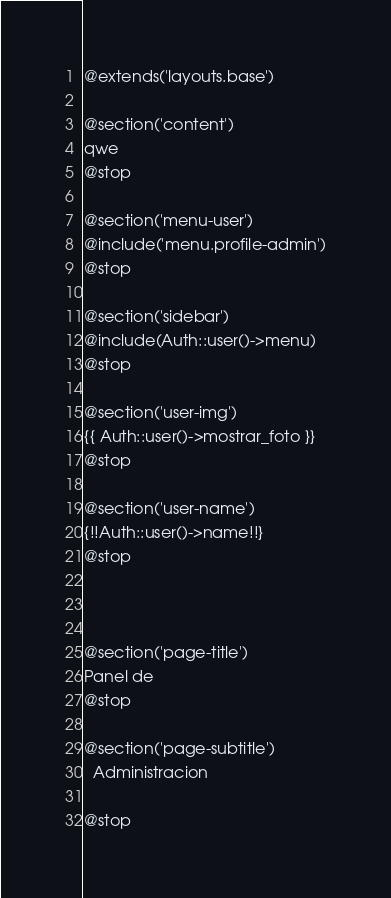<code> <loc_0><loc_0><loc_500><loc_500><_PHP_>@extends('layouts.base')

@section('content')
qwe
@stop

@section('menu-user')
@include('menu.profile-admin')
@stop

@section('sidebar')
@include(Auth::user()->menu)
@stop

@section('user-img')
{{ Auth::user()->mostrar_foto }}
@stop

@section('user-name')
{!!Auth::user()->name!!}
@stop



@section('page-title')
Panel de
@stop

@section('page-subtitle')
  Administracion

@stop




</code> 